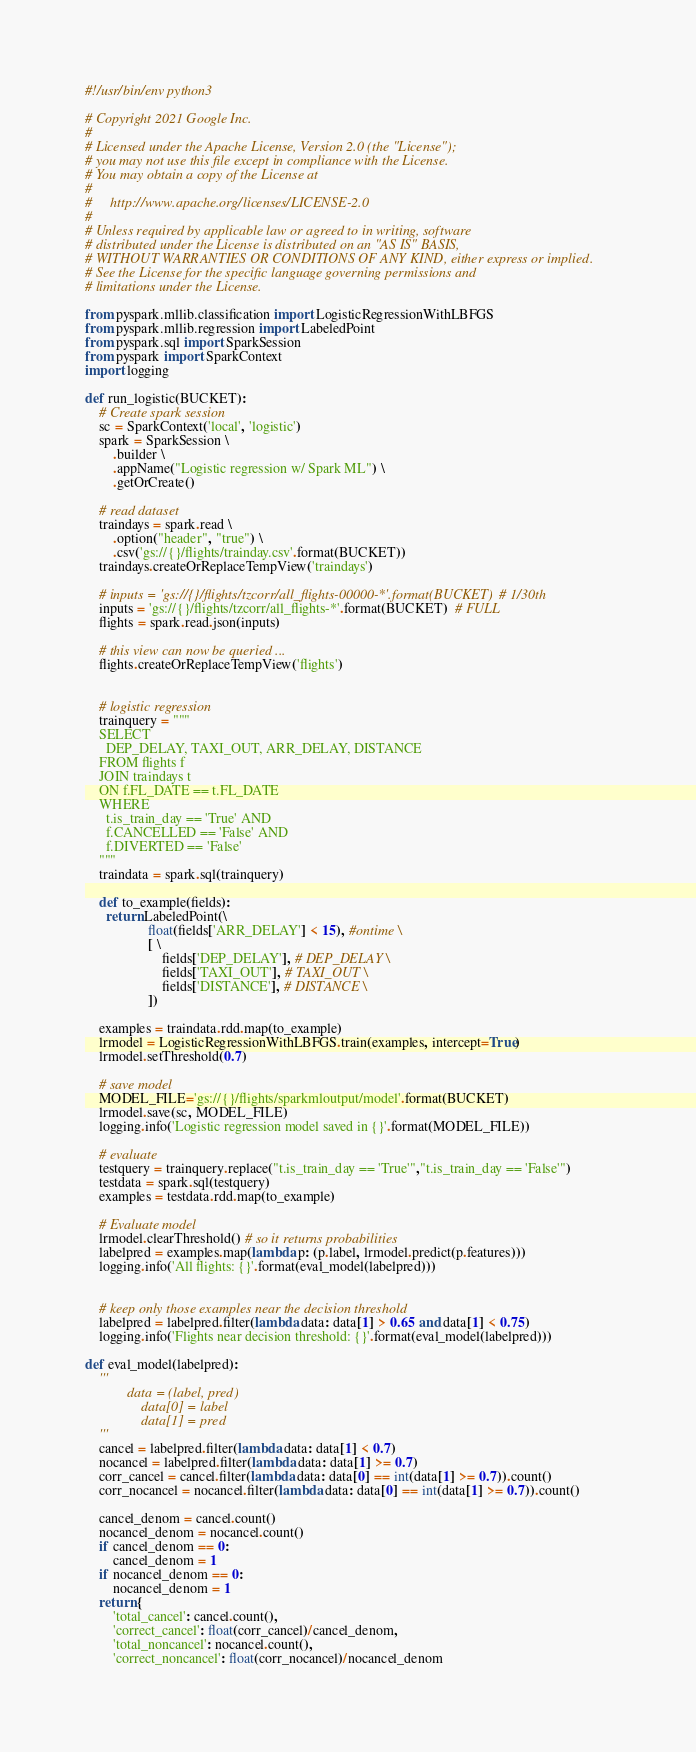<code> <loc_0><loc_0><loc_500><loc_500><_Python_>#!/usr/bin/env python3

# Copyright 2021 Google Inc.
#
# Licensed under the Apache License, Version 2.0 (the "License");
# you may not use this file except in compliance with the License.
# You may obtain a copy of the License at
#
#     http://www.apache.org/licenses/LICENSE-2.0
#
# Unless required by applicable law or agreed to in writing, software
# distributed under the License is distributed on an "AS IS" BASIS,
# WITHOUT WARRANTIES OR CONDITIONS OF ANY KIND, either express or implied.
# See the License for the specific language governing permissions and
# limitations under the License.

from pyspark.mllib.classification import LogisticRegressionWithLBFGS
from pyspark.mllib.regression import LabeledPoint
from pyspark.sql import SparkSession
from pyspark import SparkContext
import logging

def run_logistic(BUCKET):
    # Create spark session
    sc = SparkContext('local', 'logistic')
    spark = SparkSession \
        .builder \
        .appName("Logistic regression w/ Spark ML") \
        .getOrCreate()

    # read dataset
    traindays = spark.read \
        .option("header", "true") \
        .csv('gs://{}/flights/trainday.csv'.format(BUCKET))
    traindays.createOrReplaceTempView('traindays')

    # inputs = 'gs://{}/flights/tzcorr/all_flights-00000-*'.format(BUCKET)  # 1/30th
    inputs = 'gs://{}/flights/tzcorr/all_flights-*'.format(BUCKET)  # FULL
    flights = spark.read.json(inputs)

    # this view can now be queried ...
    flights.createOrReplaceTempView('flights')


    # logistic regression
    trainquery = """
    SELECT
      DEP_DELAY, TAXI_OUT, ARR_DELAY, DISTANCE
    FROM flights f
    JOIN traindays t
    ON f.FL_DATE == t.FL_DATE
    WHERE
      t.is_train_day == 'True' AND
      f.CANCELLED == 'False' AND 
      f.DIVERTED == 'False'
    """
    traindata = spark.sql(trainquery)

    def to_example(fields):
      return LabeledPoint(\
                  float(fields['ARR_DELAY'] < 15), #ontime \
                  [ \
                      fields['DEP_DELAY'], # DEP_DELAY \
                      fields['TAXI_OUT'], # TAXI_OUT \
                      fields['DISTANCE'], # DISTANCE \
                  ])

    examples = traindata.rdd.map(to_example)
    lrmodel = LogisticRegressionWithLBFGS.train(examples, intercept=True)
    lrmodel.setThreshold(0.7)

    # save model
    MODEL_FILE='gs://{}/flights/sparkmloutput/model'.format(BUCKET)
    lrmodel.save(sc, MODEL_FILE)
    logging.info('Logistic regression model saved in {}'.format(MODEL_FILE))

    # evaluate
    testquery = trainquery.replace("t.is_train_day == 'True'","t.is_train_day == 'False'")
    testdata = spark.sql(testquery)
    examples = testdata.rdd.map(to_example)

    # Evaluate model
    lrmodel.clearThreshold() # so it returns probabilities
    labelpred = examples.map(lambda p: (p.label, lrmodel.predict(p.features)))
    logging.info('All flights: {}'.format(eval_model(labelpred)))


    # keep only those examples near the decision threshold
    labelpred = labelpred.filter(lambda data: data[1] > 0.65 and data[1] < 0.75)
    logging.info('Flights near decision threshold: {}'.format(eval_model(labelpred)))

def eval_model(labelpred):
    '''
            data = (label, pred)
                data[0] = label
                data[1] = pred
    '''
    cancel = labelpred.filter(lambda data: data[1] < 0.7)
    nocancel = labelpred.filter(lambda data: data[1] >= 0.7)
    corr_cancel = cancel.filter(lambda data: data[0] == int(data[1] >= 0.7)).count()
    corr_nocancel = nocancel.filter(lambda data: data[0] == int(data[1] >= 0.7)).count()

    cancel_denom = cancel.count()
    nocancel_denom = nocancel.count()
    if cancel_denom == 0:
        cancel_denom = 1
    if nocancel_denom == 0:
        nocancel_denom = 1
    return {
        'total_cancel': cancel.count(),
        'correct_cancel': float(corr_cancel)/cancel_denom,
        'total_noncancel': nocancel.count(),
        'correct_noncancel': float(corr_nocancel)/nocancel_denom</code> 